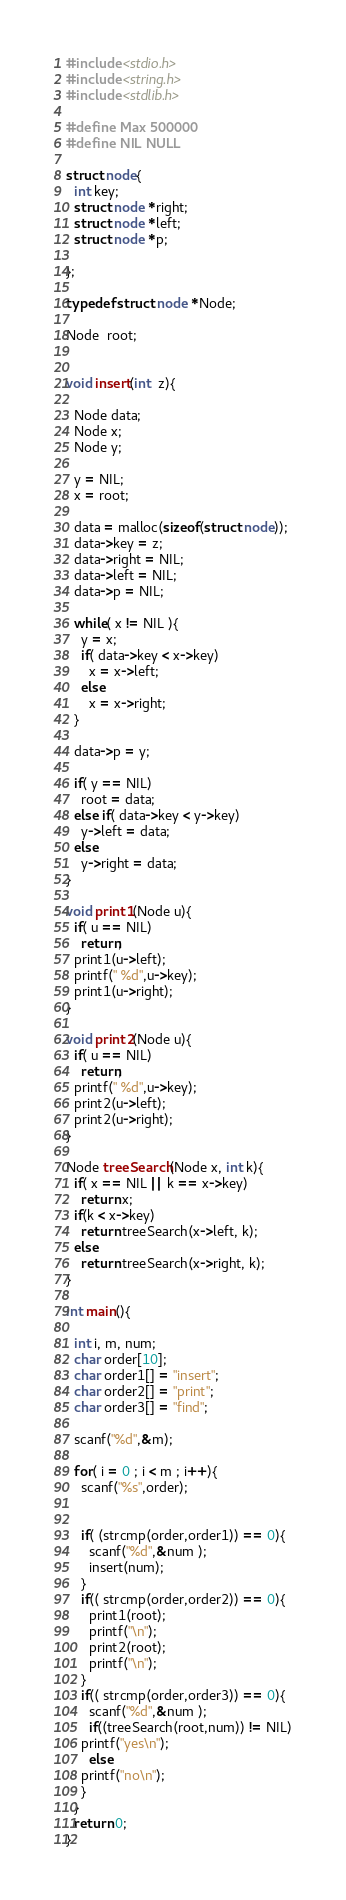Convert code to text. <code><loc_0><loc_0><loc_500><loc_500><_C_>#include <stdio.h>
#include <string.h>
#include <stdlib.h>

#define Max 500000
#define NIL NULL

struct node{
  int key;
  struct node *right;
  struct node *left;
  struct node *p; 

};

typedef struct node *Node;
 
Node  root;


void insert(int  z){

  Node data;
  Node x;
  Node y;

  y = NIL;
  x = root;

  data = malloc(sizeof(struct node));
  data->key = z;
  data->right = NIL;
  data->left = NIL;
  data->p = NIL;

  while( x != NIL ){
    y = x;
    if( data->key < x->key)
      x = x->left;
    else
      x = x->right;
  }
  
  data->p = y;
  
  if( y == NIL)
    root = data;
  else if( data->key < y->key)
    y->left = data;
  else 
    y->right = data;
}

void print1(Node u){
  if( u == NIL)
    return;
  print1(u->left);
  printf(" %d",u->key);
  print1(u->right);
}

void print2(Node u){
  if( u == NIL)
    return;
  printf(" %d",u->key);
  print2(u->left);
  print2(u->right);
}

Node treeSearch(Node x, int k){
  if( x == NIL || k == x->key)
    return x;
  if(k < x->key)
    return treeSearch(x->left, k);
  else
    return treeSearch(x->right, k);
}

int main(){

  int i, m, num;
  char order[10];
  char order1[] = "insert";
  char order2[] = "print"; 
  char order3[] = "find";

  scanf("%d",&m);

  for( i = 0 ; i < m ; i++){
    scanf("%s",order);

 
    if( (strcmp(order,order1)) == 0){
      scanf("%d",&num );
      insert(num);
    }
    if(( strcmp(order,order2)) == 0){
      print1(root);  
      printf("\n");
      print2(root);
      printf("\n");
    }
    if(( strcmp(order,order3)) == 0){
      scanf("%d",&num );
      if((treeSearch(root,num)) != NIL)
	printf("yes\n");
      else
	printf("no\n");
    }
  }
  return 0;
}</code> 